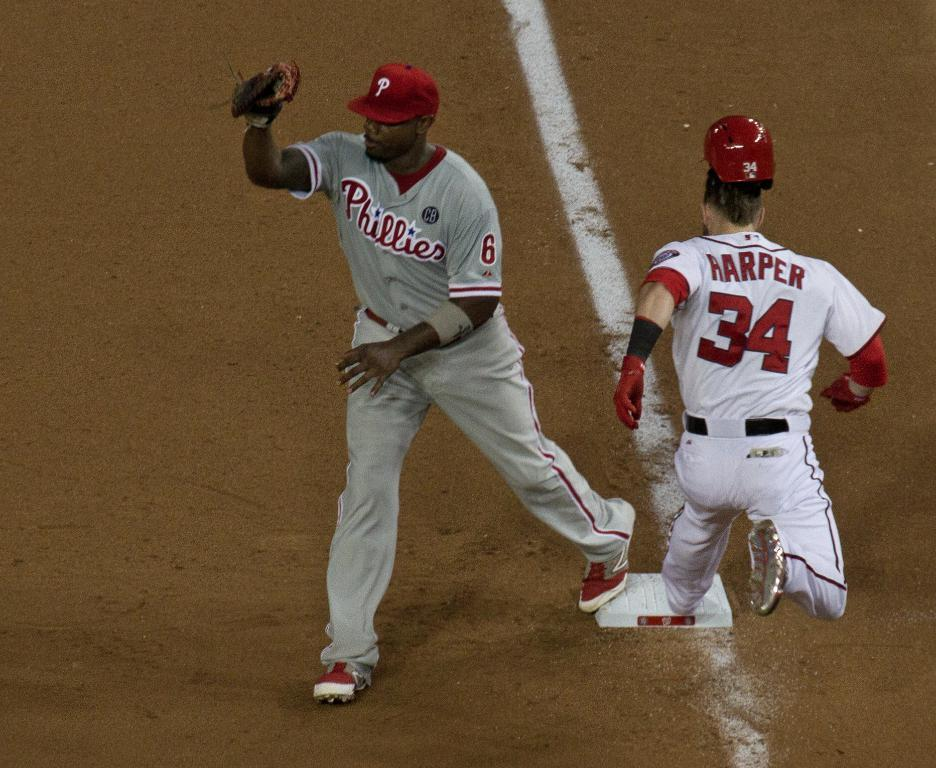<image>
Provide a brief description of the given image. Baseball player is on the base against a Phillies baseman. 